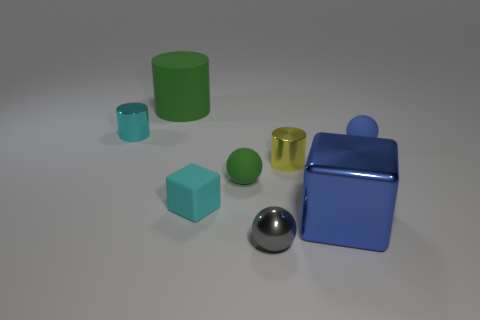Add 1 cyan rubber cylinders. How many objects exist? 9 Subtract all balls. How many objects are left? 5 Subtract all small gray objects. Subtract all tiny cyan shiny cylinders. How many objects are left? 6 Add 8 small yellow things. How many small yellow things are left? 9 Add 6 small blue things. How many small blue things exist? 7 Subtract 0 gray cubes. How many objects are left? 8 